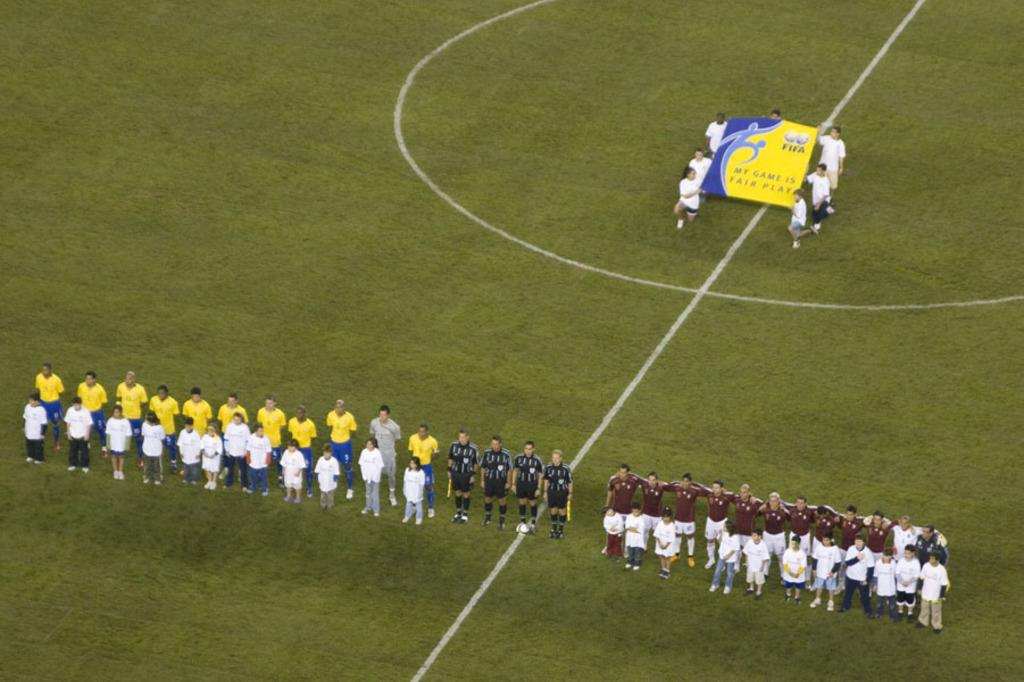What is the setting of the image? The group of people is standing on the grass. What are the people in the background doing? There is a group of people holding a board in the background. What act are the people performing on the ground in the image? There is no act or performance taking place on the ground in the image. What idea does the board held by the group of people in the background represent? The image does not provide any information about the idea or message represented by the board held by the group of people in the background. 